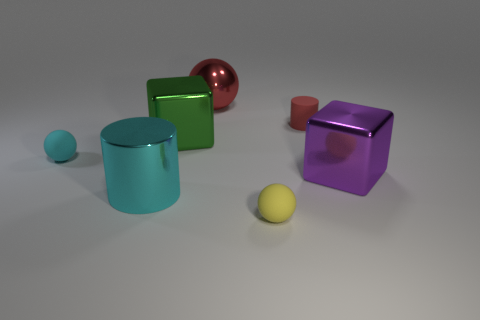The other object that is the same shape as the tiny red matte thing is what color?
Your answer should be compact. Cyan. Do the large metallic sphere and the rubber ball that is behind the large cyan metal cylinder have the same color?
Your answer should be very brief. No. The large metallic thing that is left of the big ball and to the right of the cyan shiny thing has what shape?
Offer a very short reply. Cube. Are there fewer tiny brown matte blocks than small red cylinders?
Your answer should be compact. Yes. Are there any tiny objects?
Provide a succinct answer. Yes. What number of other things are the same size as the red ball?
Your answer should be compact. 3. Do the big green cube and the cyan cylinder that is to the left of the red cylinder have the same material?
Your answer should be very brief. Yes. Are there the same number of big shiny things that are in front of the cyan metallic cylinder and red cylinders behind the big green cube?
Provide a succinct answer. No. What material is the yellow sphere?
Make the answer very short. Rubber. What color is the rubber cylinder that is the same size as the yellow sphere?
Offer a very short reply. Red. 